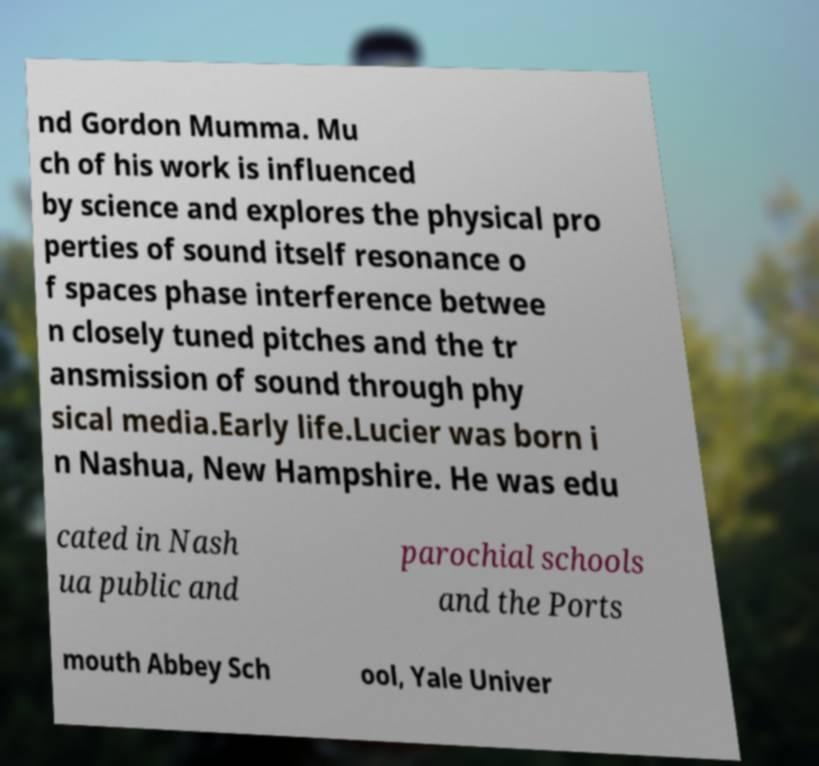I need the written content from this picture converted into text. Can you do that? nd Gordon Mumma. Mu ch of his work is influenced by science and explores the physical pro perties of sound itself resonance o f spaces phase interference betwee n closely tuned pitches and the tr ansmission of sound through phy sical media.Early life.Lucier was born i n Nashua, New Hampshire. He was edu cated in Nash ua public and parochial schools and the Ports mouth Abbey Sch ool, Yale Univer 